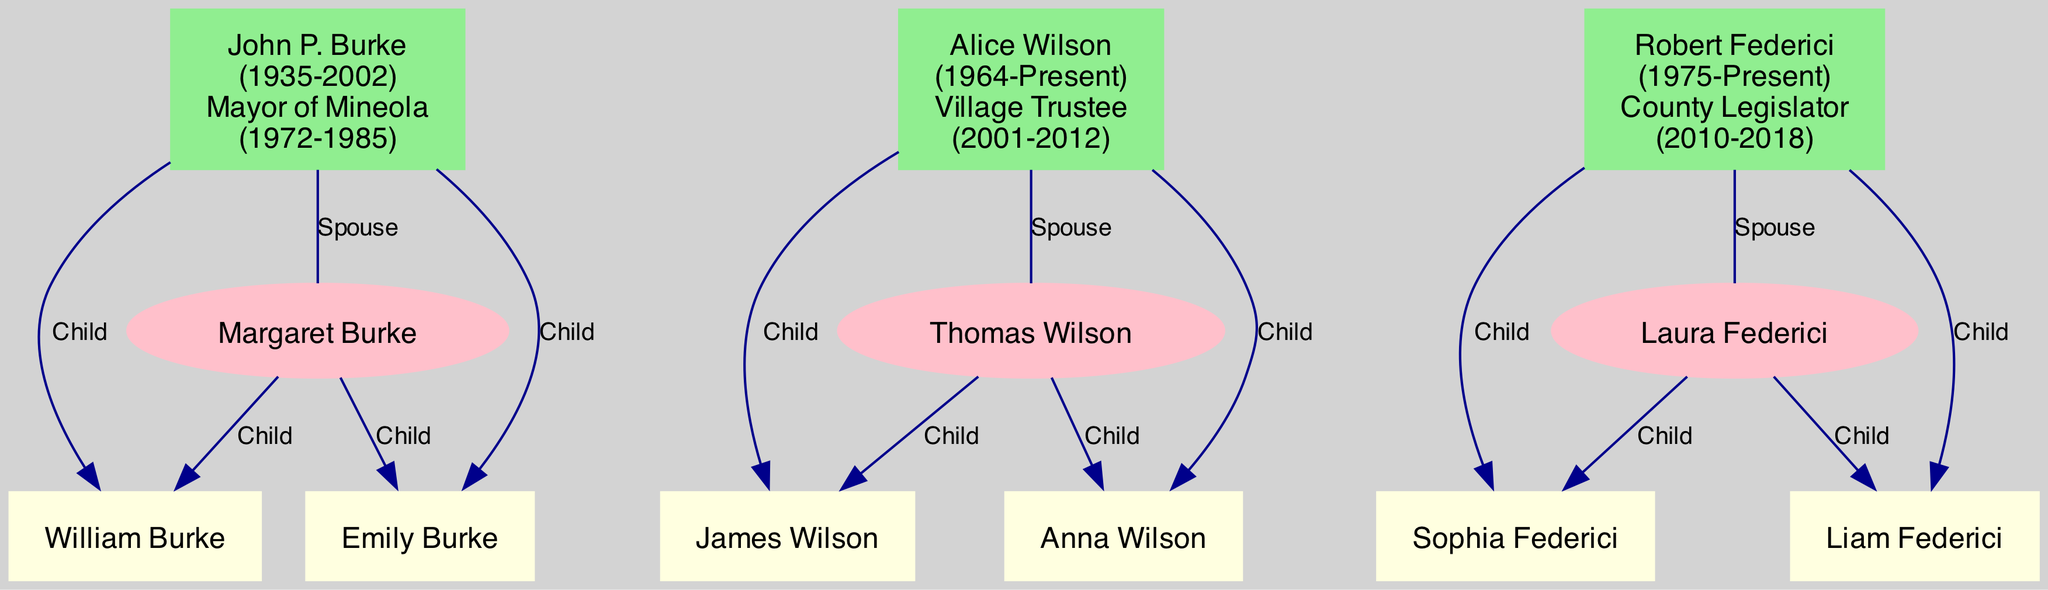What is the birth year of John P. Burke? The diagram presents John P. Burke's information, and it indicates that he was born in 1935.
Answer: 1935 How many children does Alice Wilson have? Referring to Alice Wilson's section in the diagram, it shows that she has two children: James Wilson and Anna Wilson.
Answer: 2 Who is the spouse of Robert Federici? The diagram indicates that Robert Federici's spouse is Laura Federici, clearly connected in the family structure.
Answer: Laura Federici What was the term duration of John P. Burke as Mayor? By analyzing John P. Burke's information in the diagram, it shows he served from 1972 to 1985, which is a term duration of 13 years.
Answer: 13 years Which political figure was elected after 2000? Reviewing the years in the diagram, Alice Wilson began her term as Village Trustee in 2001, thus she is the only figure elected after 2000.
Answer: Alice Wilson Which political figure has children named Sophia and Liam? Upon inspecting the family connections of Robert Federici in the diagram, it states he has two children named Sophia Federici and Liam Federici.
Answer: Robert Federici How many political figures are represented in the diagram? By counting the individual nodes for each prominent political figure, there are three political figures represented: John P. Burke, Alice Wilson, and Robert Federici.
Answer: 3 What is the relationship between Emily Burke and John P. Burke? The diagram shows that Emily Burke is listed as a child of John P. Burke, establishing a direct parent-child relationship.
Answer: Daughter Which political figure served as a County Legislator? Upon examining the roles listed in the diagram, Robert Federici is noted as serving as a County Legislator from 2010 to 2018.
Answer: Robert Federici 